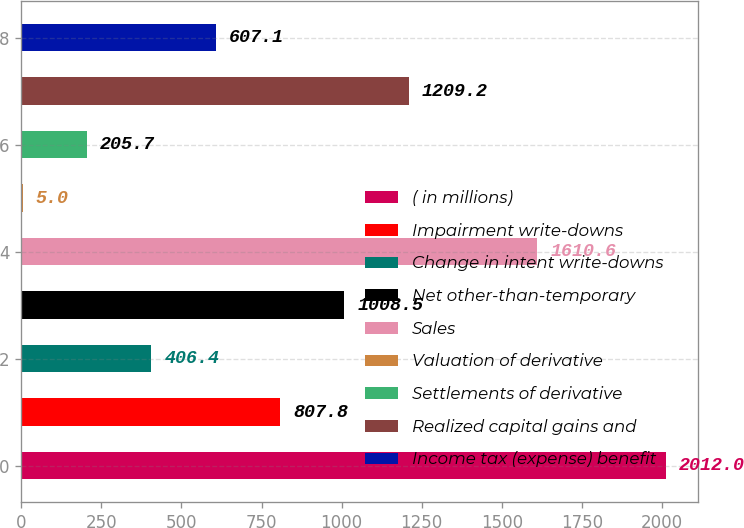<chart> <loc_0><loc_0><loc_500><loc_500><bar_chart><fcel>( in millions)<fcel>Impairment write-downs<fcel>Change in intent write-downs<fcel>Net other-than-temporary<fcel>Sales<fcel>Valuation of derivative<fcel>Settlements of derivative<fcel>Realized capital gains and<fcel>Income tax (expense) benefit<nl><fcel>2012<fcel>807.8<fcel>406.4<fcel>1008.5<fcel>1610.6<fcel>5<fcel>205.7<fcel>1209.2<fcel>607.1<nl></chart> 